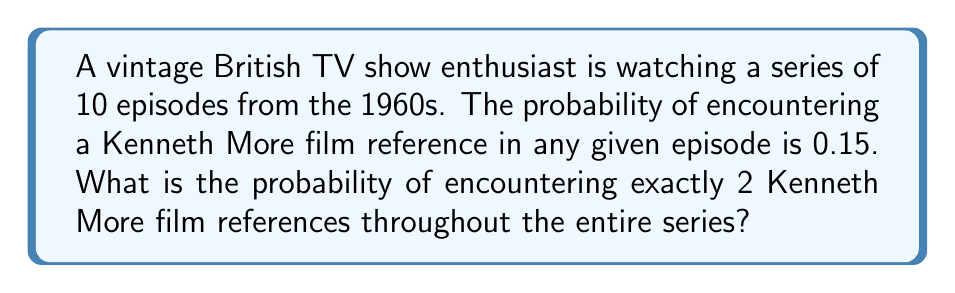What is the answer to this math problem? To solve this problem, we can use the Binomial probability distribution, as we have a fixed number of independent trials (episodes) with a constant probability of success (encountering a Kenneth More film reference).

Let's break it down step-by-step:

1. Identify the parameters:
   - $n$ = number of trials (episodes) = 10
   - $p$ = probability of success (encountering a reference) = 0.15
   - $k$ = number of successes we're interested in = 2

2. The formula for Binomial probability is:

   $$ P(X=k) = \binom{n}{k} p^k (1-p)^{n-k} $$

3. Calculate the binomial coefficient:
   
   $$ \binom{10}{2} = \frac{10!}{2!(10-2)!} = \frac{10 \cdot 9}{2 \cdot 1} = 45 $$

4. Substitute the values into the formula:

   $$ P(X=2) = 45 \cdot (0.15)^2 \cdot (1-0.15)^{10-2} $$

5. Simplify:
   
   $$ P(X=2) = 45 \cdot (0.15)^2 \cdot (0.85)^8 $$
   $$ P(X=2) = 45 \cdot 0.0225 \cdot 0.2725 $$
   $$ P(X=2) = 0.2757 $$

6. Round to four decimal places:
   
   $$ P(X=2) \approx 0.2757 $$

Therefore, the probability of encountering exactly 2 Kenneth More film references in the 10-episode series is approximately 0.2757 or 27.57%.
Answer: 0.2757 